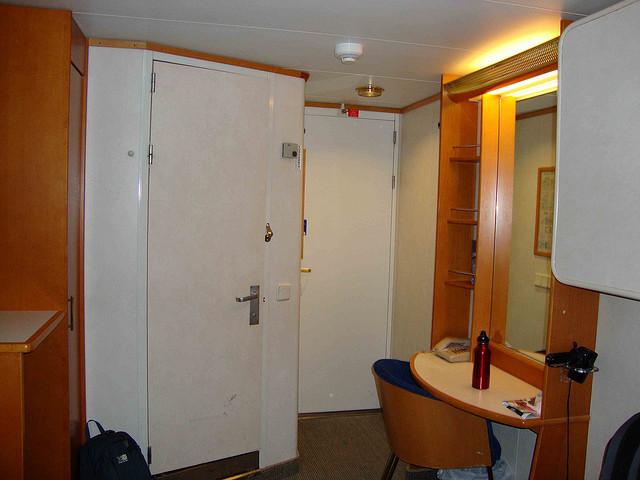How many plate mates are shown on the table?
Quick response, please. 0. What color are the walls?
Concise answer only. White. What is in the center of the desk?
Concise answer only. Bottle. Where is the smoke alarm?
Quick response, please. Ceiling. Do you see a mirror in this photo?
Be succinct. Yes. 